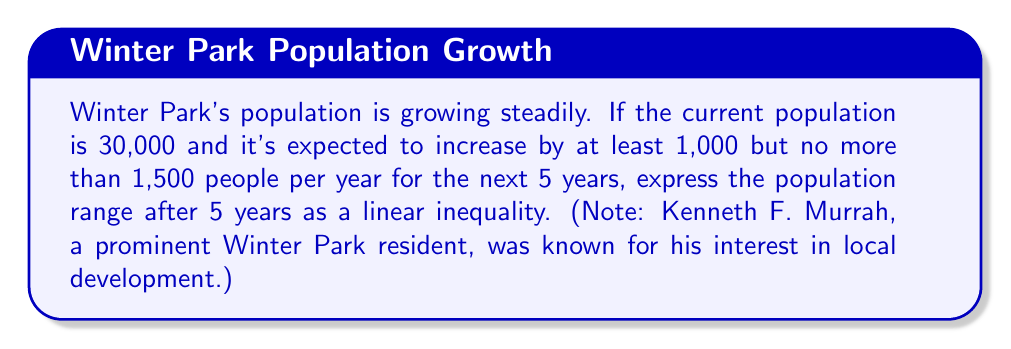Give your solution to this math problem. Let's approach this step-by-step:

1) Let $P$ represent the population after 5 years.

2) The current population is 30,000.

3) The minimum increase per year is 1,000, so over 5 years:
   Minimum total increase = $5 \times 1,000 = 5,000$

4) The maximum increase per year is 1,500, so over 5 years:
   Maximum total increase = $5 \times 1,500 = 7,500$

5) Therefore, after 5 years:
   Minimum population = $30,000 + 5,000 = 35,000$
   Maximum population = $30,000 + 7,500 = 37,500$

6) We can express this as an inequality:
   $35,000 \leq P \leq 37,500$

7) To write this as a linear inequality, we can subtract 30,000 from each part:
   $5,000 \leq P - 30,000 \leq 7,500$

This linear inequality models the population growth in Winter Park over the next 5 years.
Answer: $5,000 \leq P - 30,000 \leq 7,500$, where $P$ is the population after 5 years 